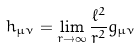<formula> <loc_0><loc_0><loc_500><loc_500>h _ { \mu \nu } = \lim _ { r \rightarrow \infty } \frac { \ell ^ { 2 } } { r ^ { 2 } } g _ { \mu \nu }</formula> 